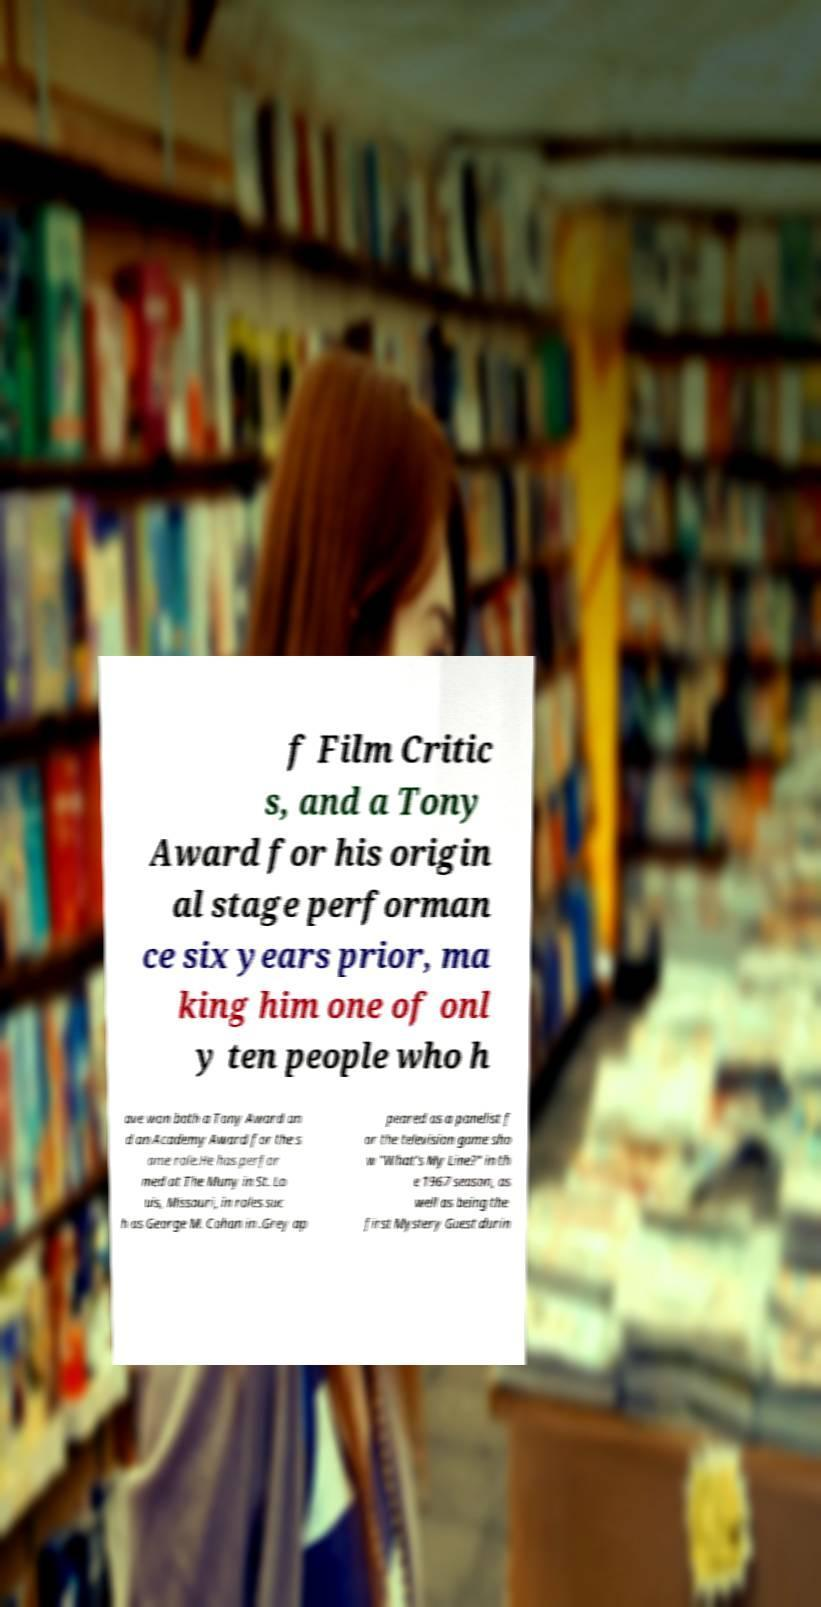There's text embedded in this image that I need extracted. Can you transcribe it verbatim? f Film Critic s, and a Tony Award for his origin al stage performan ce six years prior, ma king him one of onl y ten people who h ave won both a Tony Award an d an Academy Award for the s ame role.He has perfor med at The Muny in St. Lo uis, Missouri, in roles suc h as George M. Cohan in .Grey ap peared as a panelist f or the television game sho w "What's My Line?" in th e 1967 season, as well as being the first Mystery Guest durin 